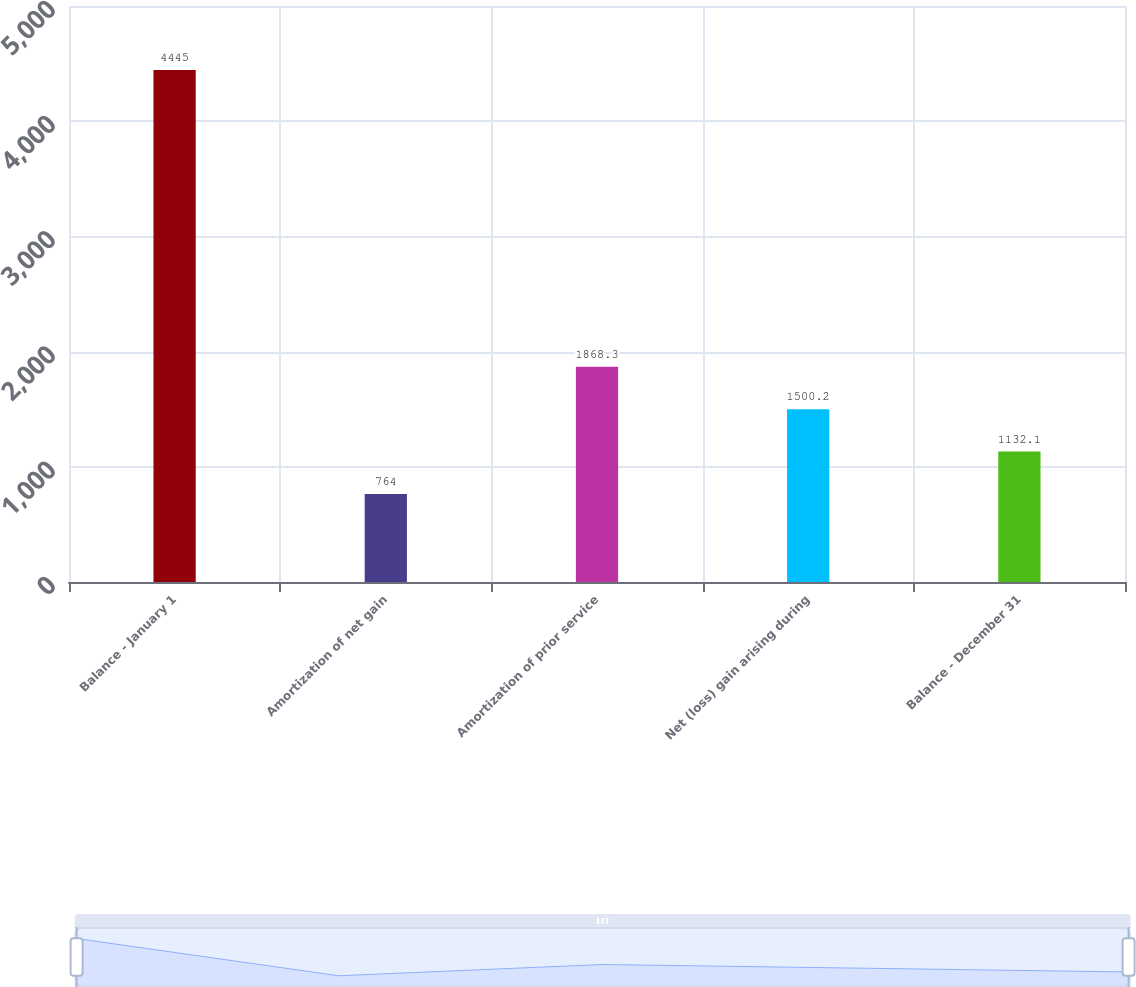Convert chart. <chart><loc_0><loc_0><loc_500><loc_500><bar_chart><fcel>Balance - January 1<fcel>Amortization of net gain<fcel>Amortization of prior service<fcel>Net (loss) gain arising during<fcel>Balance - December 31<nl><fcel>4445<fcel>764<fcel>1868.3<fcel>1500.2<fcel>1132.1<nl></chart> 